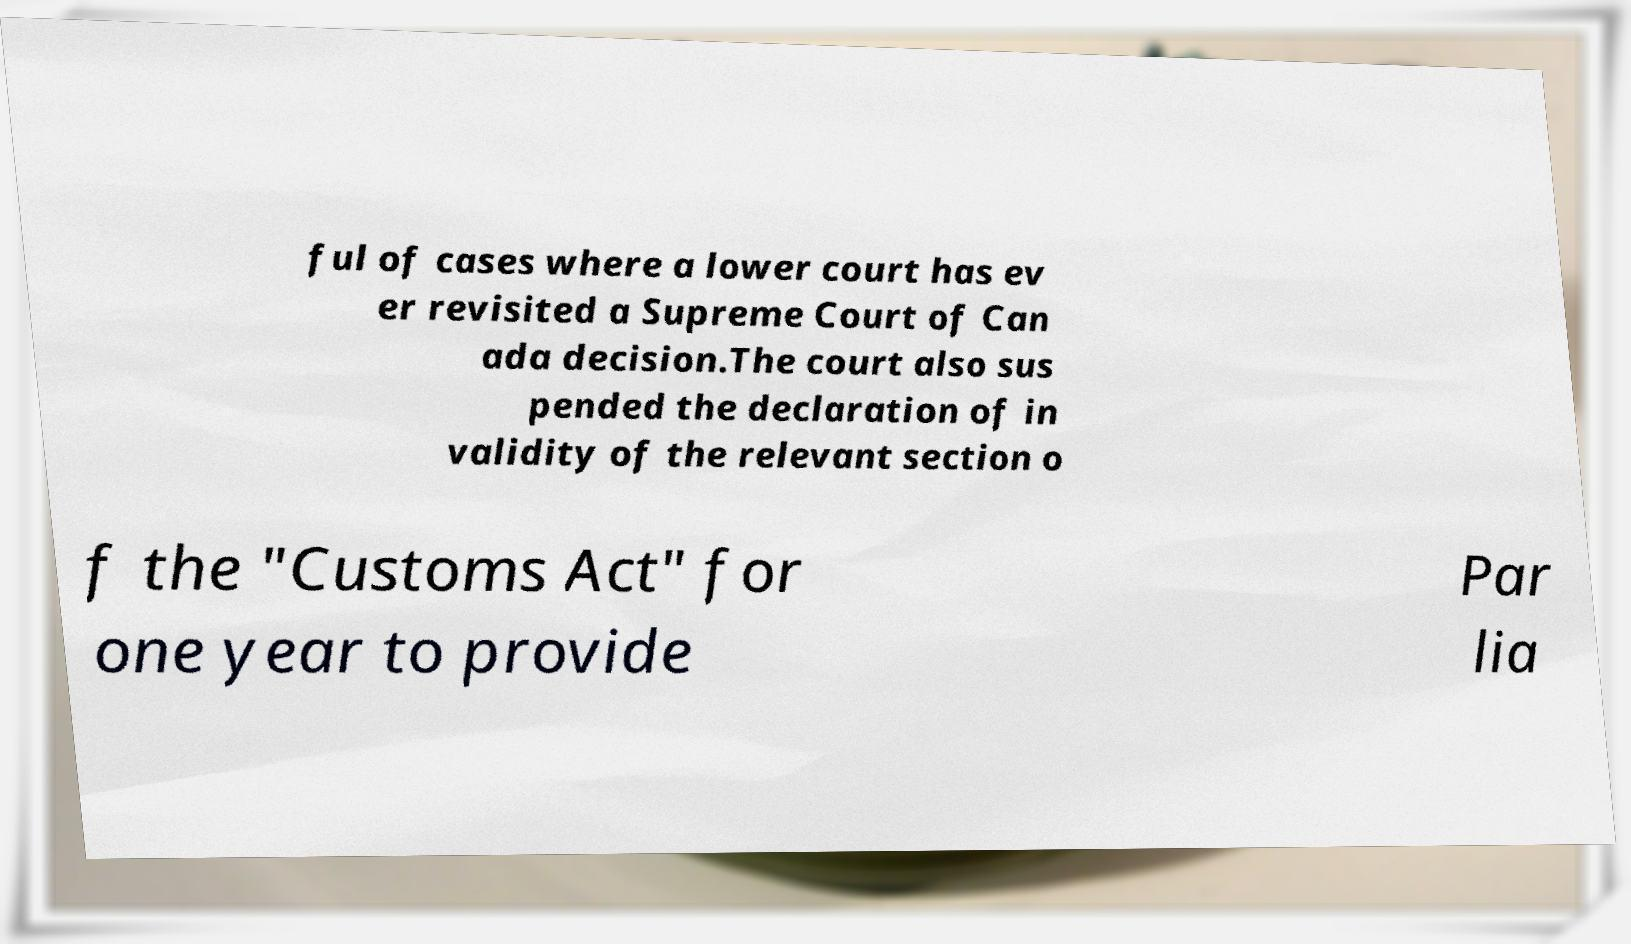Could you assist in decoding the text presented in this image and type it out clearly? ful of cases where a lower court has ev er revisited a Supreme Court of Can ada decision.The court also sus pended the declaration of in validity of the relevant section o f the "Customs Act" for one year to provide Par lia 